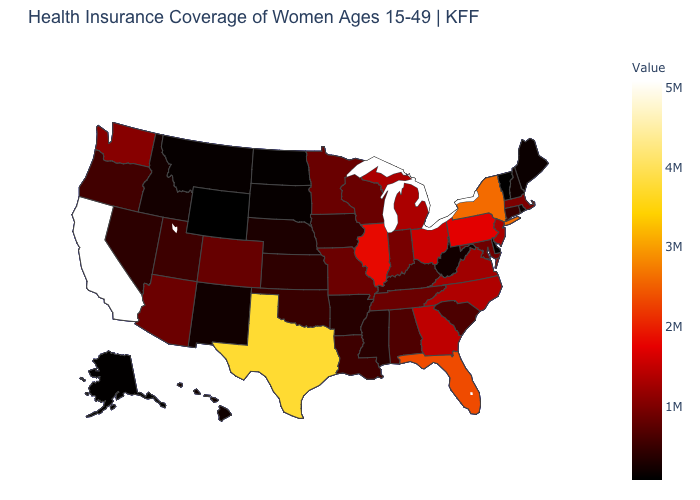Is the legend a continuous bar?
Answer briefly. Yes. Which states have the lowest value in the USA?
Give a very brief answer. Wyoming. Does Wyoming have the lowest value in the USA?
Answer briefly. Yes. Which states have the highest value in the USA?
Keep it brief. California. Does California have the highest value in the West?
Short answer required. Yes. Which states have the lowest value in the MidWest?
Quick response, please. North Dakota. Which states have the highest value in the USA?
Quick response, please. California. 